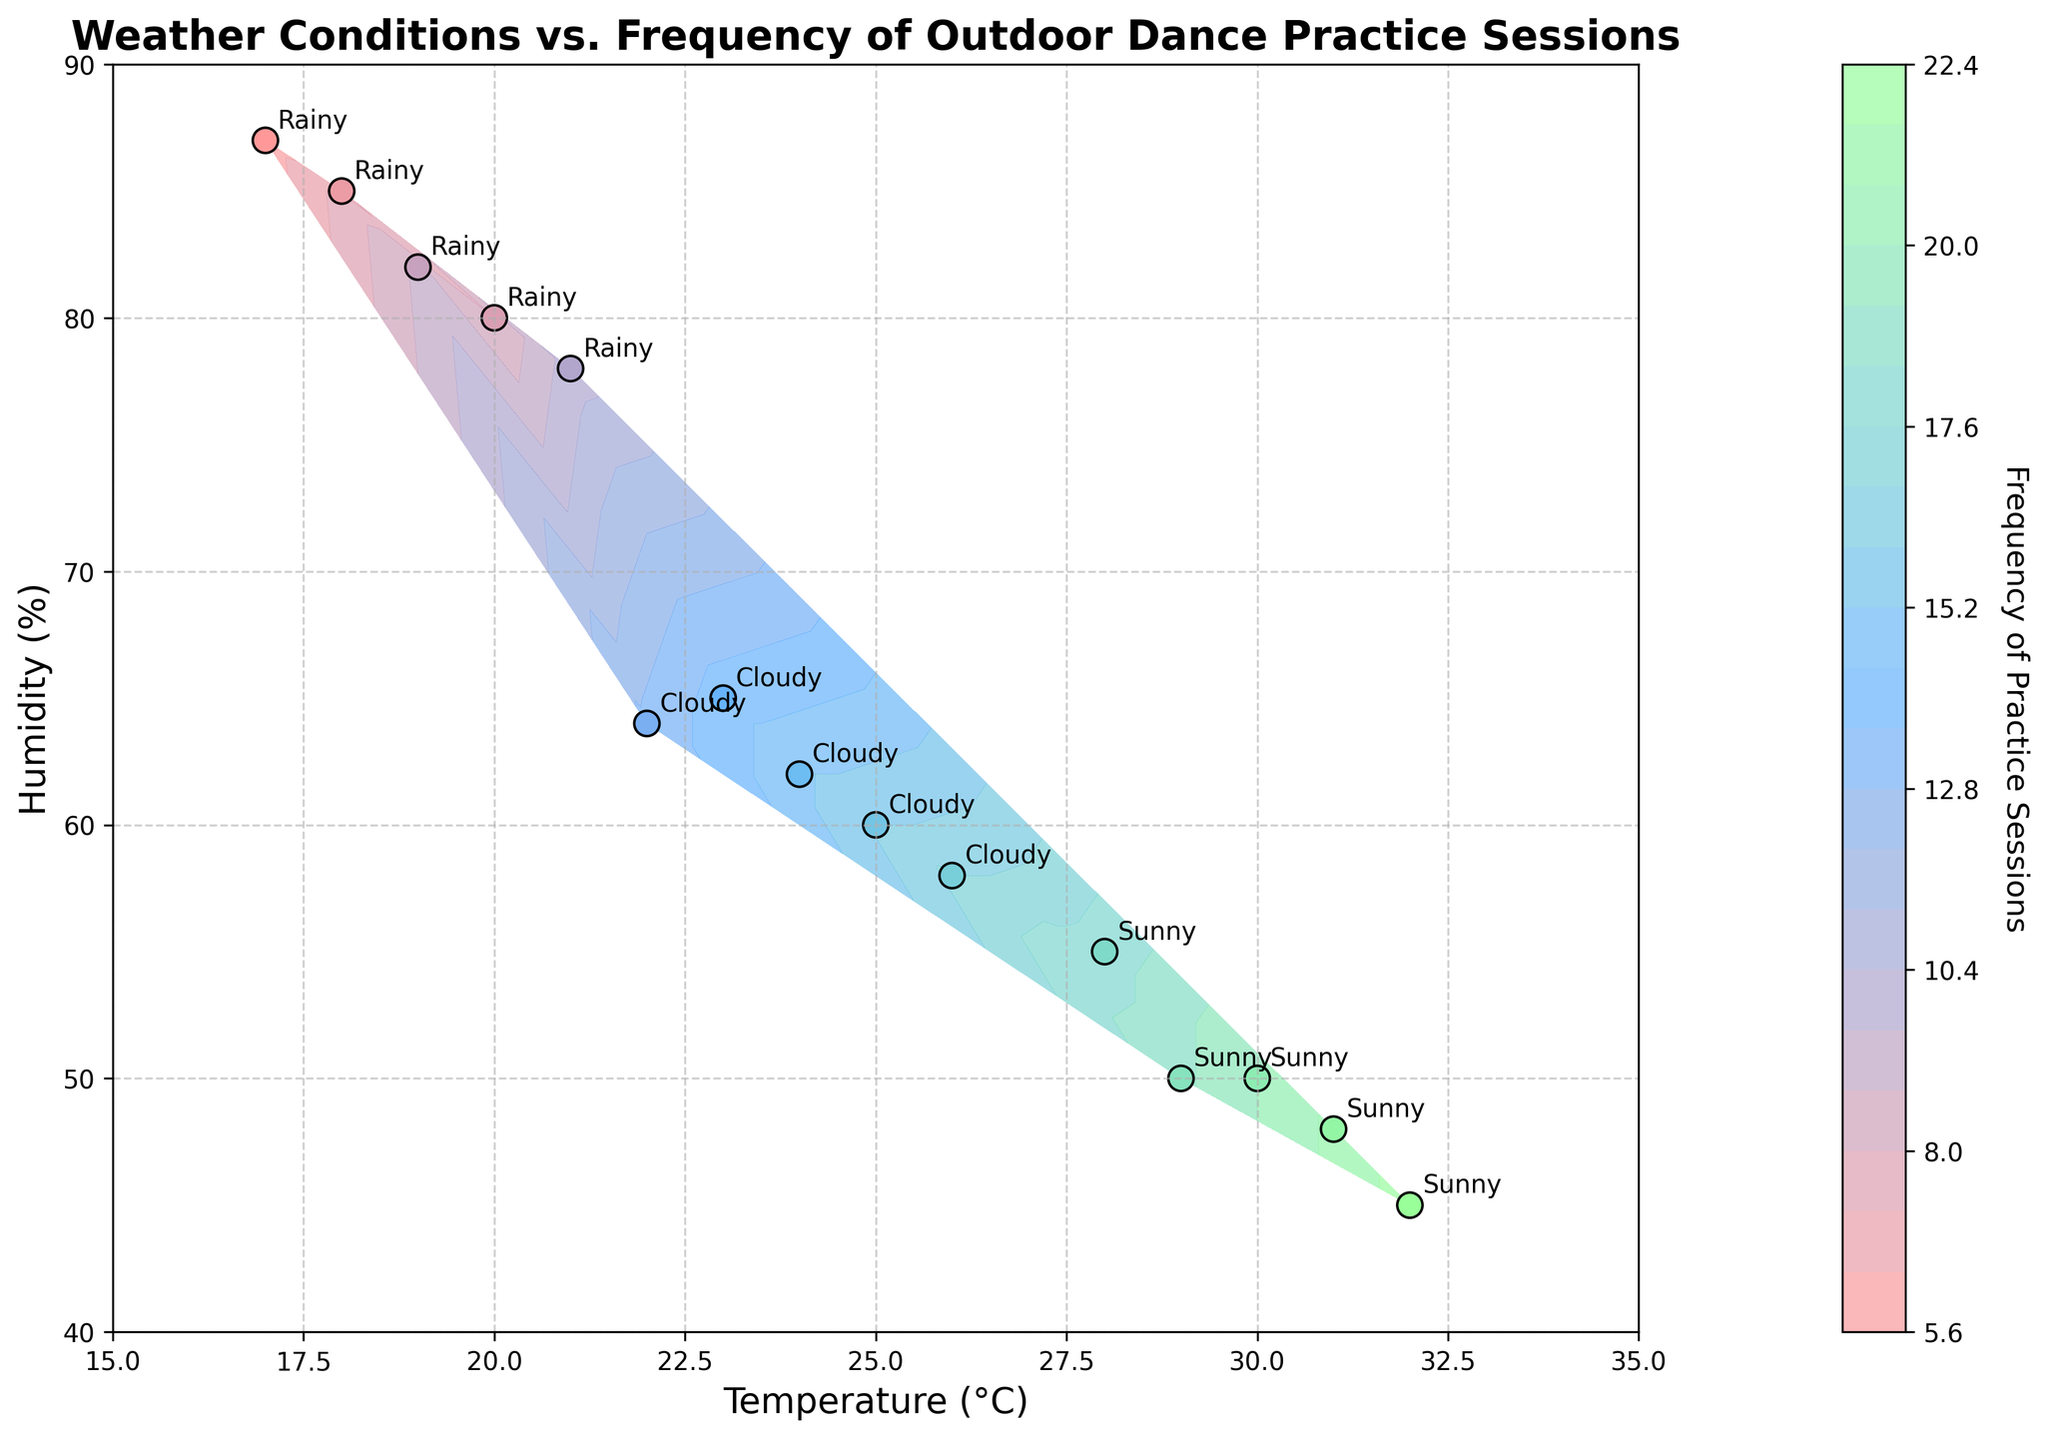What is the title of the figure? The title of the figure is located at the top and reads "Weather Conditions vs. Frequency of Outdoor Dance Practice Sessions."
Answer: Weather Conditions vs. Frequency of Outdoor Dance Practice Sessions Which weather condition has the highest frequency of practice sessions? The legend and labels on the plot indicate that the highest frequency occurs under 'Sunny' conditions, as seen by the higher frequency values in the contour and data points.
Answer: Sunny What are the ranges of the Temperature (°C) and Humidity (%) axes? The x-axis represents Temperature (°C) ranging from 15 to 35, and the y-axis represents Humidity (%) ranging from 40 to 90.
Answer: Temperature: 15-35, Humidity: 40-90 How does the frequency of practice sessions differ between 'Sunny' and 'Rainy' conditions? 'Sunny' conditions show frequencies around 18-22, while 'Rainy' conditions have much lower frequencies around 6-10. This can be observed by comparing the colored contour regions and scatter plot points labeled as 'Sunny' versus 'Rainy.'
Answer: Sunny: 18-22, Rainy: 6-10 What visual elements are used to represent the frequency of practice sessions? The frequency is represented by color gradients on the contour plot, ranging from lighter to darker shades, and by the color of scatter plot points. More frequent sessions are indicated by darker or more intense colors.
Answer: Color gradients, scatter plot points Are practice sessions more frequent under 'Cloudy' or 'Rainy' conditions? By comparing the contour plot colors and scatter plot points for 'Cloudy' and 'Rainy' labels, 'Cloudy' conditions show higher frequencies (13-17) than 'Rainy' conditions (6-10).
Answer: Cloudy What color represents the highest frequency of practice sessions, and under which conditions is this observed? The highest frequency of practice sessions is represented by a darker red color on the contour plot, which is observed under 'Sunny' conditions.
Answer: Dark red, Sunny Which data point represents the 'Cloudy' condition with the highest frequency of practice sessions? In the scatter plot, the 'Cloudy' condition with the highest frequency (17) is found at the point labeled 'Cloudy' with the coordinates closest to (26, 58).
Answer: (26, 58) What trend can you observe between temperature, humidity, and the frequency of practice sessions? Higher temperatures and moderate humidity levels correlate with higher frequencies of practice sessions. Lower temperatures and higher humidity levels tend to correlate with lower frequencies. This trend can be seen in the scatter plot and contour levels.
Answer: High temp/moderate humidity -> High frequency; Low temp/high humidity -> Low frequency 